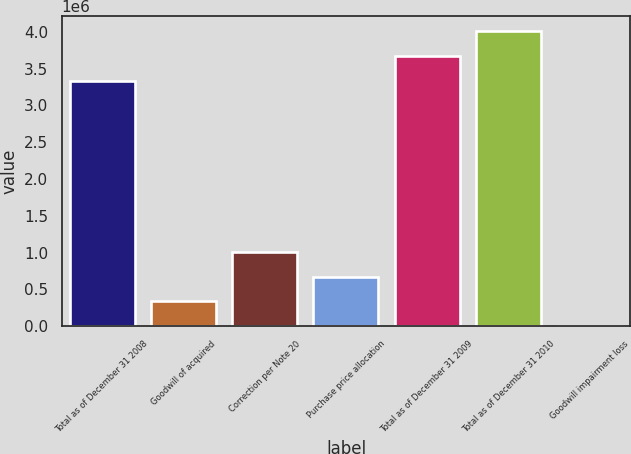Convert chart. <chart><loc_0><loc_0><loc_500><loc_500><bar_chart><fcel>Total as of December 31 2008<fcel>Goodwill of acquired<fcel>Correction per Note 20<fcel>Purchase price allocation<fcel>Total as of December 31 2009<fcel>Total as of December 31 2010<fcel>Goodwill impairment loss<nl><fcel>3.33813e+06<fcel>334971<fcel>1.00491e+06<fcel>669939<fcel>3.6731e+06<fcel>4.00807e+06<fcel>3.37<nl></chart> 